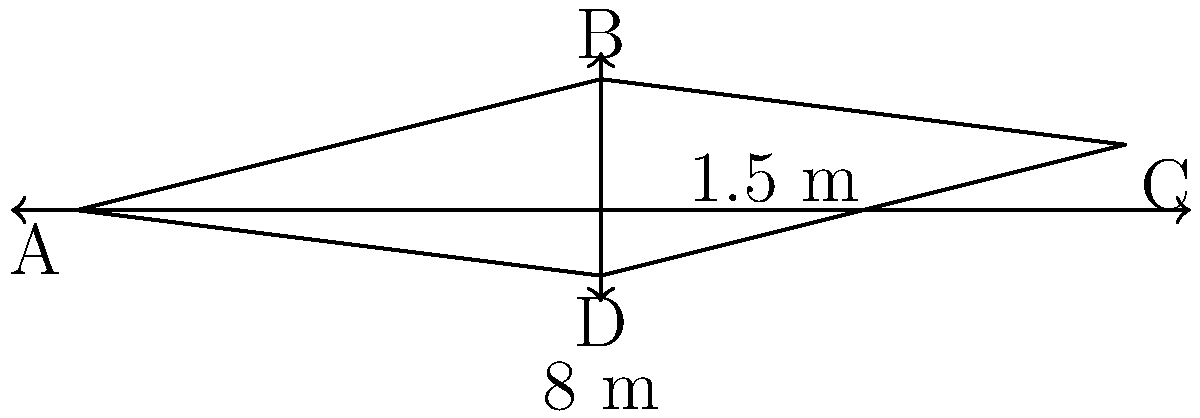An airplane wing's cross-sectional airfoil shape is approximated by a quadrilateral ABCD, as shown in the figure. If the chord length (AC) is 8 meters and the maximum thickness (BD) is 1.5 meters, calculate the cross-sectional area of the airfoil in square meters. Assume the shape can be divided into two trapezoids. To calculate the cross-sectional area of the airfoil, we'll divide it into two trapezoids and sum their areas. Let's approach this step-by-step:

1) The shape can be divided into trapezoids ABD and BCD.

2) For a trapezoid, the area is given by the formula: 
   $$A = \frac{1}{2}(b_1 + b_2)h$$
   where $b_1$ and $b_2$ are the parallel sides and $h$ is the height.

3) For trapezoid ABD:
   - Base 1 (AD) ≈ 4 m (half of total length)
   - Base 2 (AB) = 4 m
   - Height = 1 m
   Area of ABD = $\frac{1}{2}(4 + 4) * 1 = 4$ m²

4) For trapezoid BCD:
   - Base 1 (BC) = 4 m
   - Base 2 (CD) ≈ 4 m (half of total length)
   - Height = 0.5 m
   Area of BCD = $\frac{1}{2}(4 + 4) * 0.5 = 2$ m²

5) Total area = Area of ABD + Area of BCD
               = 4 m² + 2 m² = 6 m²

Therefore, the cross-sectional area of the airfoil is approximately 6 square meters.
Answer: 6 m² 